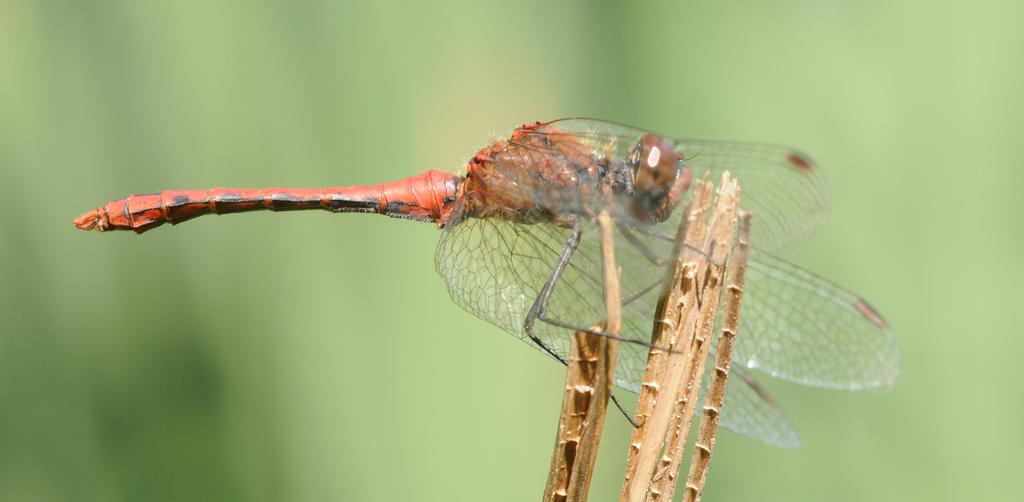What is the main subject of the image? In the first transcript, the main subject is a person sitting on a chair and reading a book. What is the person doing in the image? The person is sitting on a chair and reading a book. What is present on the table next to the chair? There is a cup of coffee on the table. How many quarters can be seen in the image? There are no quarters present in the image. --- What is the main subject of the image? In the second transcript, the main subject is a group of people standing in front of a building. What are the people holding in the image? The people are holding banners and flags. Reasoning: Let's think step by step in order to produce the conversation. We start by identifying the main subject of the image, which is a group of people standing in front of a building. Next, we describe the objects that the people are holding, noting that they are holding banners and flags. Absurd Question/Answer: What type of knife is being used to trade in the image? There is no knife or trade present in the image. --- What is the main subject of the image? In the third transcript, the main subject is a person holding a camera and taking a picture of a landscape. What is the person doing in the image? The person is holding a camera and taking a picture of a landscape. Reasoning: Let's think step by step in order to produce the conversation. We start by identifying the main subject of the image, which is a person holding a camera and taking a picture of a landscape. Next, we describe the person's actions, noting that they are holding a camera and taking a picture. Absurd Question/Answer: What type of trade is being conducted with the camera in the image? There is no trade present in the image. 